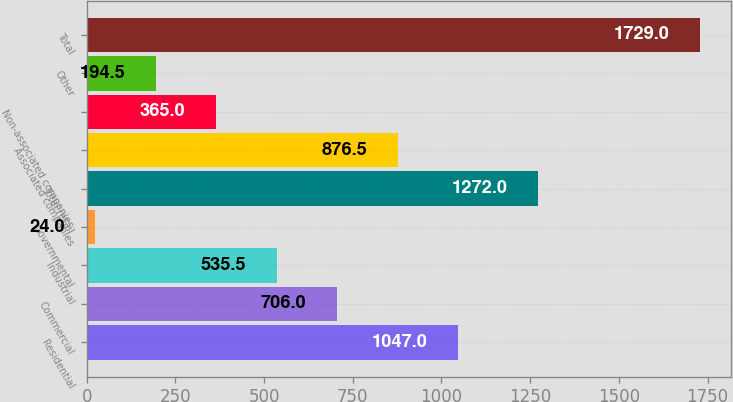Convert chart. <chart><loc_0><loc_0><loc_500><loc_500><bar_chart><fcel>Residential<fcel>Commercial<fcel>Industrial<fcel>Governmental<fcel>Total retail<fcel>Associated companies<fcel>Non-associated companies<fcel>Other<fcel>Total<nl><fcel>1047<fcel>706<fcel>535.5<fcel>24<fcel>1272<fcel>876.5<fcel>365<fcel>194.5<fcel>1729<nl></chart> 